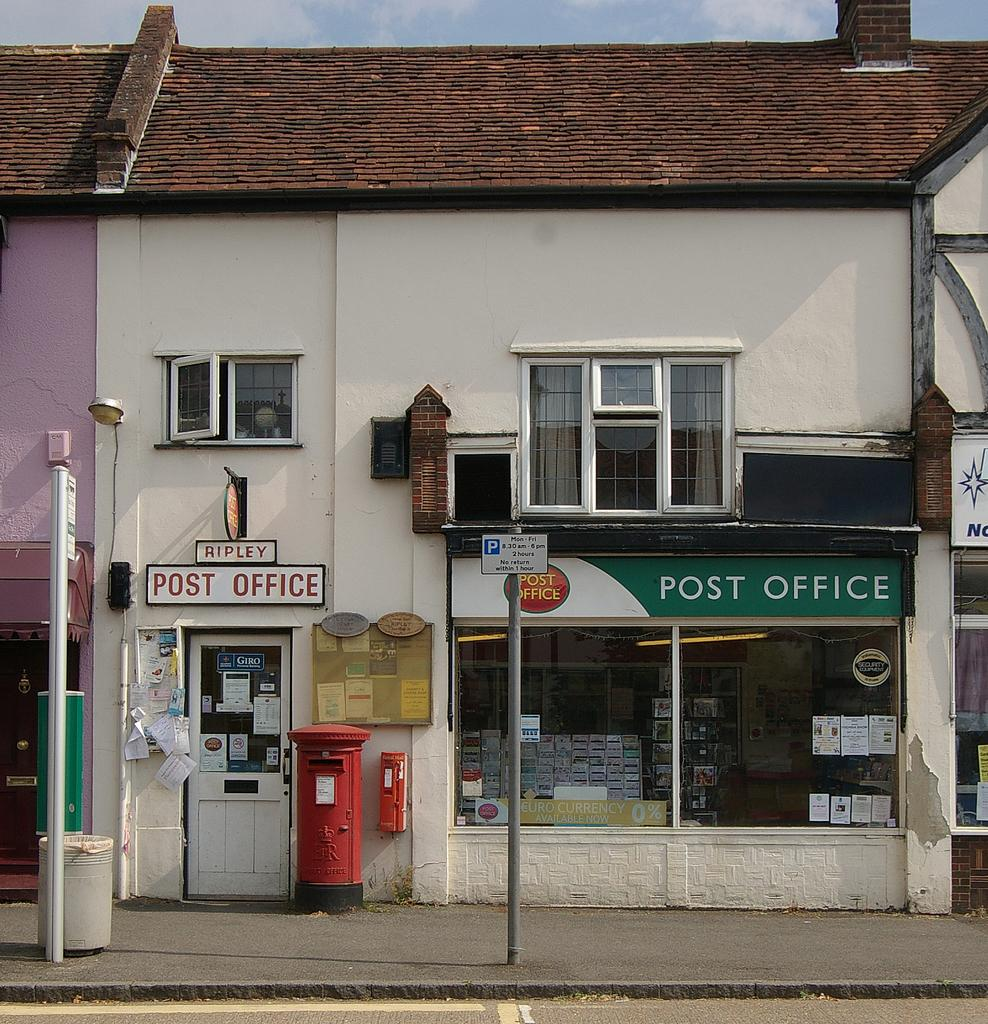What type of pathway is present in the image? There is a road and a sidewalk in the image. What structures can be seen in the image? There are poles, boards, and a building in the image. Can you describe the building in the image? The building is white and brown in color and has a window. What is visible in the background of the image? The sky is visible in the background of the image. What type of cord is hanging from the building in the image? There is no cord hanging from the building in the image. What mass of paste can be seen on the sidewalk in the image? There is no paste present on the sidewalk in the image. 